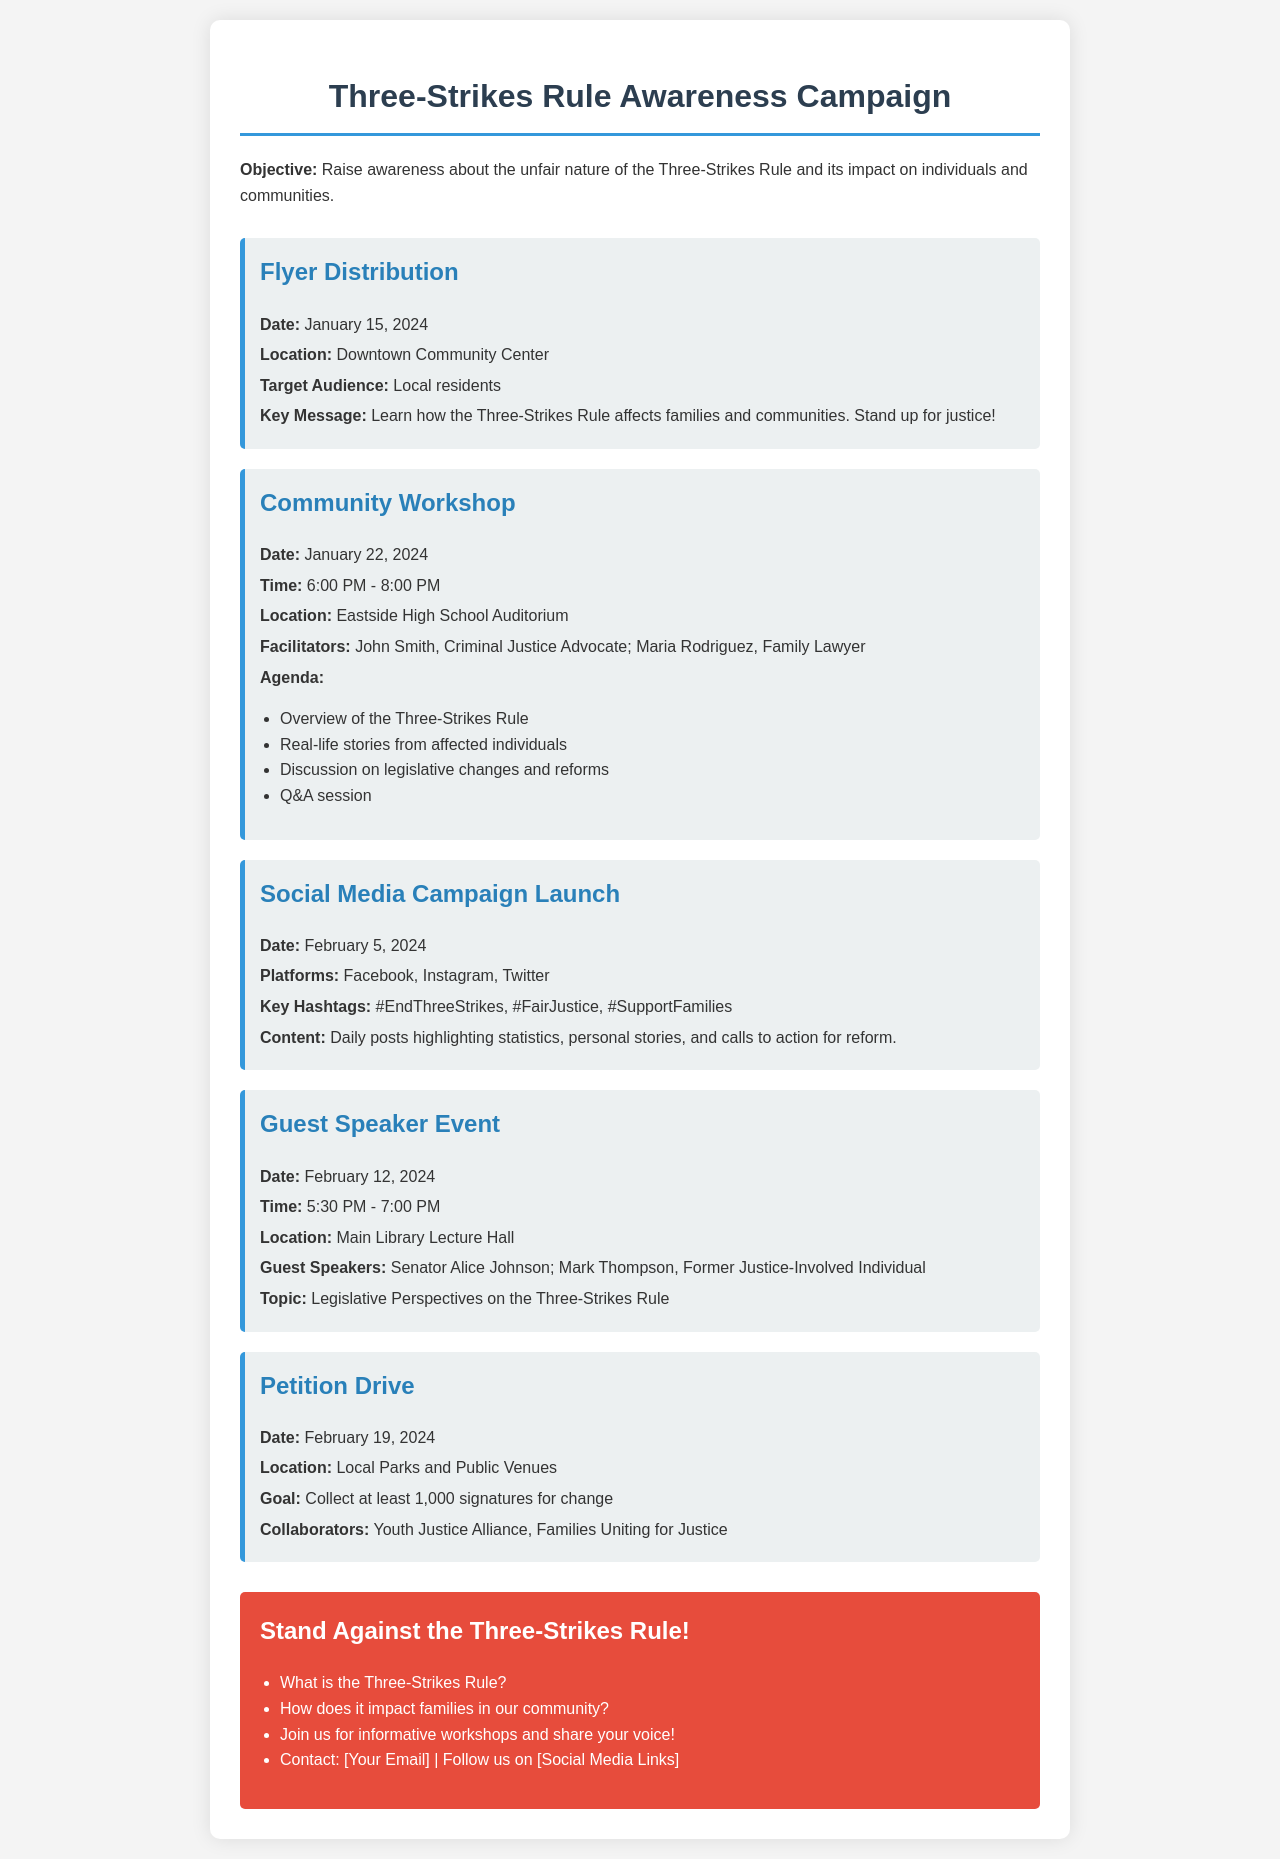What is the date for the Flyer Distribution? The date provided in the document for the Flyer Distribution is January 15, 2024.
Answer: January 15, 2024 Who are the facilitators of the Community Workshop? The document lists John Smith and Maria Rodriguez as the facilitators for the Community Workshop.
Answer: John Smith, Maria Rodriguez What is the goal of the Petition Drive? The goal stated in the document for the Petition Drive is to collect at least 1,000 signatures for change.
Answer: At least 1,000 signatures When is the Social Media Campaign Launch scheduled? The Social Media Campaign Launch is scheduled for February 5, 2024, as noted in the document.
Answer: February 5, 2024 What is the main topic of the Guest Speaker Event? The main topic of the Guest Speaker Event is legislative perspectives on the Three-Strikes Rule, as indicated in the document.
Answer: Legislative Perspectives on the Three-Strikes Rule What are the key hashtags for the Social Media Campaign? The document mentions the key hashtags as #EndThreeStrikes, #FairJustice, and #SupportFamilies.
Answer: #EndThreeStrikes, #FairJustice, #SupportFamilies What type of event is happening on January 22, 2024? The event scheduled for January 22, 2024, is a Community Workshop, according to the document.
Answer: Community Workshop 